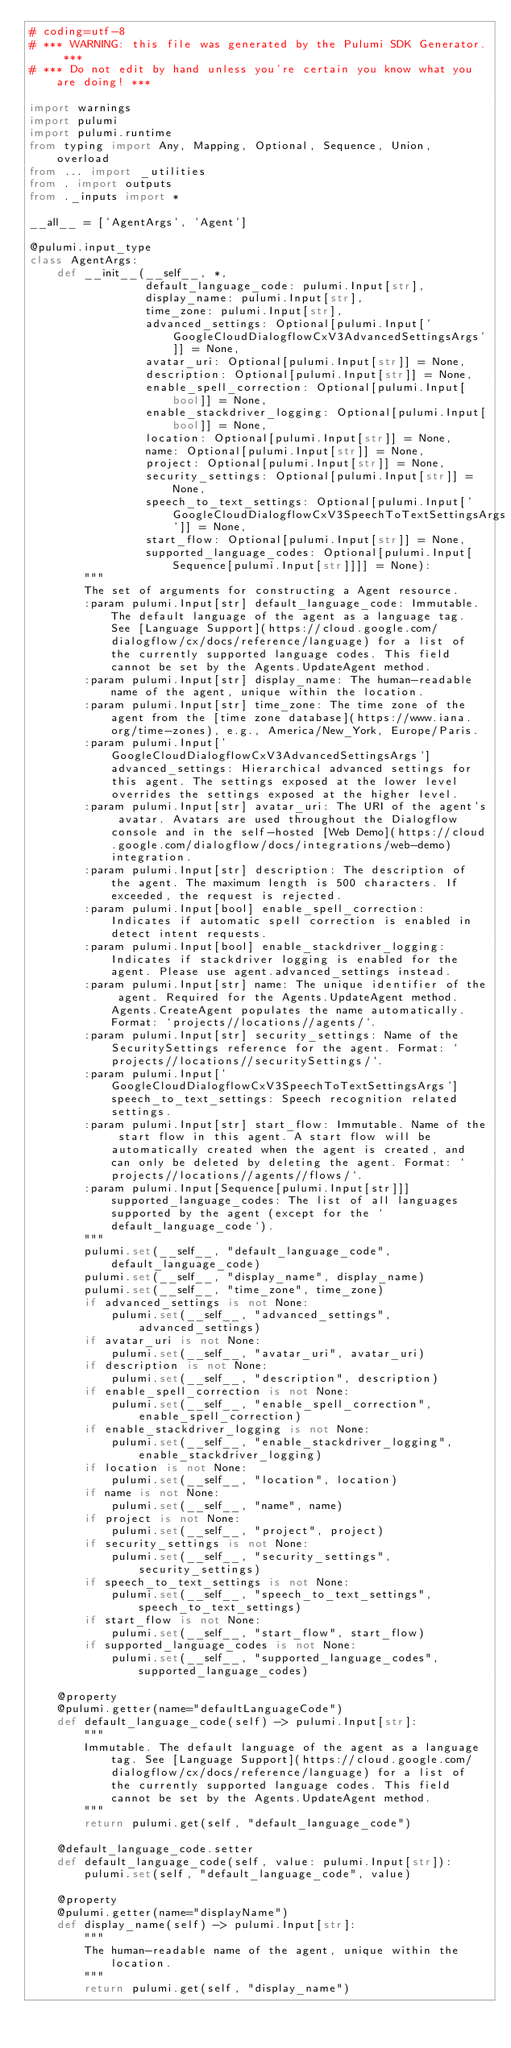Convert code to text. <code><loc_0><loc_0><loc_500><loc_500><_Python_># coding=utf-8
# *** WARNING: this file was generated by the Pulumi SDK Generator. ***
# *** Do not edit by hand unless you're certain you know what you are doing! ***

import warnings
import pulumi
import pulumi.runtime
from typing import Any, Mapping, Optional, Sequence, Union, overload
from ... import _utilities
from . import outputs
from ._inputs import *

__all__ = ['AgentArgs', 'Agent']

@pulumi.input_type
class AgentArgs:
    def __init__(__self__, *,
                 default_language_code: pulumi.Input[str],
                 display_name: pulumi.Input[str],
                 time_zone: pulumi.Input[str],
                 advanced_settings: Optional[pulumi.Input['GoogleCloudDialogflowCxV3AdvancedSettingsArgs']] = None,
                 avatar_uri: Optional[pulumi.Input[str]] = None,
                 description: Optional[pulumi.Input[str]] = None,
                 enable_spell_correction: Optional[pulumi.Input[bool]] = None,
                 enable_stackdriver_logging: Optional[pulumi.Input[bool]] = None,
                 location: Optional[pulumi.Input[str]] = None,
                 name: Optional[pulumi.Input[str]] = None,
                 project: Optional[pulumi.Input[str]] = None,
                 security_settings: Optional[pulumi.Input[str]] = None,
                 speech_to_text_settings: Optional[pulumi.Input['GoogleCloudDialogflowCxV3SpeechToTextSettingsArgs']] = None,
                 start_flow: Optional[pulumi.Input[str]] = None,
                 supported_language_codes: Optional[pulumi.Input[Sequence[pulumi.Input[str]]]] = None):
        """
        The set of arguments for constructing a Agent resource.
        :param pulumi.Input[str] default_language_code: Immutable. The default language of the agent as a language tag. See [Language Support](https://cloud.google.com/dialogflow/cx/docs/reference/language) for a list of the currently supported language codes. This field cannot be set by the Agents.UpdateAgent method.
        :param pulumi.Input[str] display_name: The human-readable name of the agent, unique within the location.
        :param pulumi.Input[str] time_zone: The time zone of the agent from the [time zone database](https://www.iana.org/time-zones), e.g., America/New_York, Europe/Paris.
        :param pulumi.Input['GoogleCloudDialogflowCxV3AdvancedSettingsArgs'] advanced_settings: Hierarchical advanced settings for this agent. The settings exposed at the lower level overrides the settings exposed at the higher level.
        :param pulumi.Input[str] avatar_uri: The URI of the agent's avatar. Avatars are used throughout the Dialogflow console and in the self-hosted [Web Demo](https://cloud.google.com/dialogflow/docs/integrations/web-demo) integration.
        :param pulumi.Input[str] description: The description of the agent. The maximum length is 500 characters. If exceeded, the request is rejected.
        :param pulumi.Input[bool] enable_spell_correction: Indicates if automatic spell correction is enabled in detect intent requests.
        :param pulumi.Input[bool] enable_stackdriver_logging: Indicates if stackdriver logging is enabled for the agent. Please use agent.advanced_settings instead.
        :param pulumi.Input[str] name: The unique identifier of the agent. Required for the Agents.UpdateAgent method. Agents.CreateAgent populates the name automatically. Format: `projects//locations//agents/`.
        :param pulumi.Input[str] security_settings: Name of the SecuritySettings reference for the agent. Format: `projects//locations//securitySettings/`.
        :param pulumi.Input['GoogleCloudDialogflowCxV3SpeechToTextSettingsArgs'] speech_to_text_settings: Speech recognition related settings.
        :param pulumi.Input[str] start_flow: Immutable. Name of the start flow in this agent. A start flow will be automatically created when the agent is created, and can only be deleted by deleting the agent. Format: `projects//locations//agents//flows/`.
        :param pulumi.Input[Sequence[pulumi.Input[str]]] supported_language_codes: The list of all languages supported by the agent (except for the `default_language_code`).
        """
        pulumi.set(__self__, "default_language_code", default_language_code)
        pulumi.set(__self__, "display_name", display_name)
        pulumi.set(__self__, "time_zone", time_zone)
        if advanced_settings is not None:
            pulumi.set(__self__, "advanced_settings", advanced_settings)
        if avatar_uri is not None:
            pulumi.set(__self__, "avatar_uri", avatar_uri)
        if description is not None:
            pulumi.set(__self__, "description", description)
        if enable_spell_correction is not None:
            pulumi.set(__self__, "enable_spell_correction", enable_spell_correction)
        if enable_stackdriver_logging is not None:
            pulumi.set(__self__, "enable_stackdriver_logging", enable_stackdriver_logging)
        if location is not None:
            pulumi.set(__self__, "location", location)
        if name is not None:
            pulumi.set(__self__, "name", name)
        if project is not None:
            pulumi.set(__self__, "project", project)
        if security_settings is not None:
            pulumi.set(__self__, "security_settings", security_settings)
        if speech_to_text_settings is not None:
            pulumi.set(__self__, "speech_to_text_settings", speech_to_text_settings)
        if start_flow is not None:
            pulumi.set(__self__, "start_flow", start_flow)
        if supported_language_codes is not None:
            pulumi.set(__self__, "supported_language_codes", supported_language_codes)

    @property
    @pulumi.getter(name="defaultLanguageCode")
    def default_language_code(self) -> pulumi.Input[str]:
        """
        Immutable. The default language of the agent as a language tag. See [Language Support](https://cloud.google.com/dialogflow/cx/docs/reference/language) for a list of the currently supported language codes. This field cannot be set by the Agents.UpdateAgent method.
        """
        return pulumi.get(self, "default_language_code")

    @default_language_code.setter
    def default_language_code(self, value: pulumi.Input[str]):
        pulumi.set(self, "default_language_code", value)

    @property
    @pulumi.getter(name="displayName")
    def display_name(self) -> pulumi.Input[str]:
        """
        The human-readable name of the agent, unique within the location.
        """
        return pulumi.get(self, "display_name")
</code> 